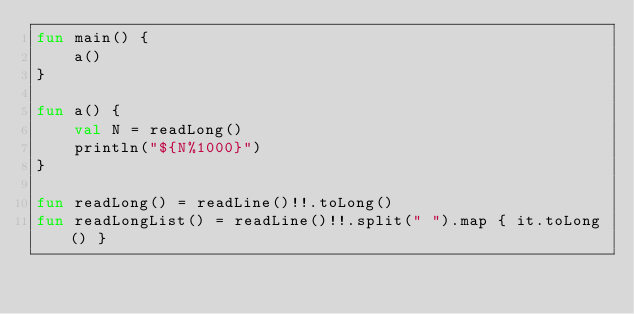<code> <loc_0><loc_0><loc_500><loc_500><_Kotlin_>fun main() {
    a()
}

fun a() {
    val N = readLong()
    println("${N%1000}")
}

fun readLong() = readLine()!!.toLong()
fun readLongList() = readLine()!!.split(" ").map { it.toLong() }</code> 